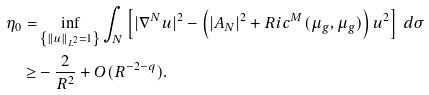<formula> <loc_0><loc_0><loc_500><loc_500>\eta _ { 0 } = & \inf _ { \left \{ \| u \| _ { L ^ { 2 } } = 1 \right \} } \int _ { N } \left [ | \nabla ^ { N } u | ^ { 2 } - \left ( | A _ { N } | ^ { 2 } + R i c ^ { M } ( \mu _ { g } , \mu _ { g } ) \right ) u ^ { 2 } \right ] \, d \sigma \\ \geq & - \frac { 2 } { R ^ { 2 } } + O ( R ^ { - 2 - q } ) .</formula> 